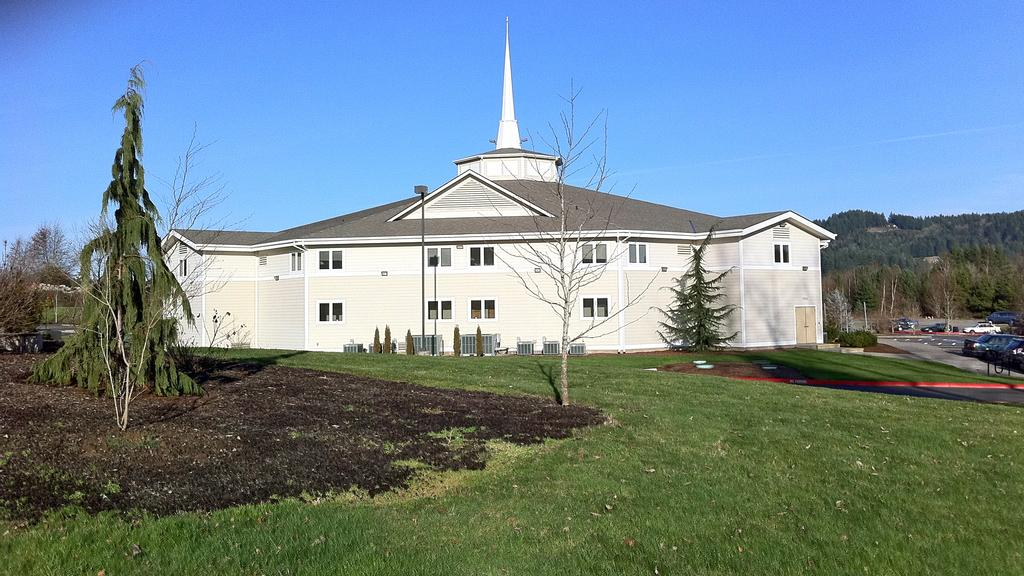What type of structure is visible in the image? There is a building in the image. What other natural elements can be seen in the image? There are trees in the image. What mode of transportation can be seen on the left side of the image? There are cars on the road on the left side of the image. What is visible in the background of the image? The sky is visible in the background of the image. What type of ground cover is present at the bottom of the image? There is grass at the bottom of the image. How many beds can be seen in the image? There are no beds present in the image. What type of breath is visible coming from the person in the image? There is no person present in the image, and therefore no breath can be observed. 